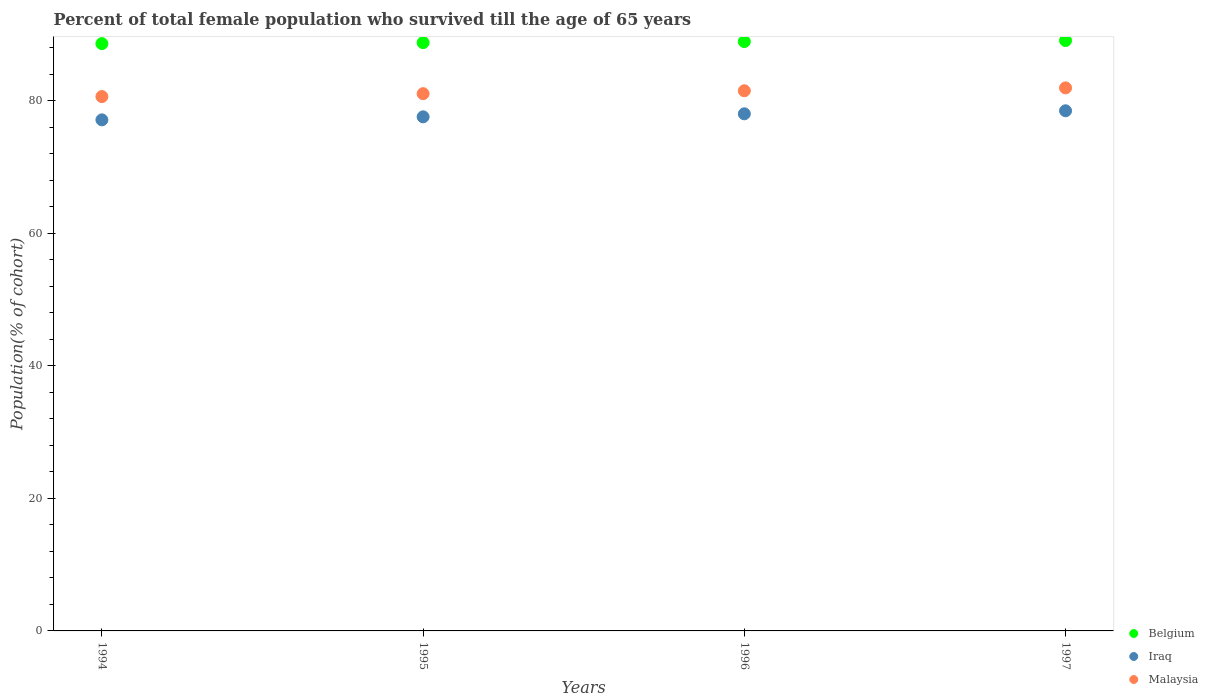How many different coloured dotlines are there?
Offer a very short reply. 3. What is the percentage of total female population who survived till the age of 65 years in Iraq in 1995?
Your answer should be very brief. 77.61. Across all years, what is the maximum percentage of total female population who survived till the age of 65 years in Belgium?
Offer a terse response. 89.12. Across all years, what is the minimum percentage of total female population who survived till the age of 65 years in Belgium?
Give a very brief answer. 88.66. What is the total percentage of total female population who survived till the age of 65 years in Malaysia in the graph?
Offer a very short reply. 325.29. What is the difference between the percentage of total female population who survived till the age of 65 years in Iraq in 1996 and that in 1997?
Make the answer very short. -0.46. What is the difference between the percentage of total female population who survived till the age of 65 years in Belgium in 1994 and the percentage of total female population who survived till the age of 65 years in Iraq in 1997?
Your answer should be very brief. 10.14. What is the average percentage of total female population who survived till the age of 65 years in Belgium per year?
Give a very brief answer. 88.89. In the year 1994, what is the difference between the percentage of total female population who survived till the age of 65 years in Belgium and percentage of total female population who survived till the age of 65 years in Malaysia?
Make the answer very short. 7.99. What is the ratio of the percentage of total female population who survived till the age of 65 years in Iraq in 1995 to that in 1997?
Your answer should be very brief. 0.99. Is the percentage of total female population who survived till the age of 65 years in Belgium in 1994 less than that in 1997?
Ensure brevity in your answer.  Yes. What is the difference between the highest and the second highest percentage of total female population who survived till the age of 65 years in Malaysia?
Provide a short and direct response. 0.44. What is the difference between the highest and the lowest percentage of total female population who survived till the age of 65 years in Iraq?
Your answer should be compact. 1.37. In how many years, is the percentage of total female population who survived till the age of 65 years in Iraq greater than the average percentage of total female population who survived till the age of 65 years in Iraq taken over all years?
Your response must be concise. 2. Is the sum of the percentage of total female population who survived till the age of 65 years in Belgium in 1994 and 1996 greater than the maximum percentage of total female population who survived till the age of 65 years in Iraq across all years?
Make the answer very short. Yes. Is it the case that in every year, the sum of the percentage of total female population who survived till the age of 65 years in Iraq and percentage of total female population who survived till the age of 65 years in Malaysia  is greater than the percentage of total female population who survived till the age of 65 years in Belgium?
Your answer should be compact. Yes. How many dotlines are there?
Your answer should be compact. 3. What is the difference between two consecutive major ticks on the Y-axis?
Offer a terse response. 20. Are the values on the major ticks of Y-axis written in scientific E-notation?
Make the answer very short. No. Does the graph contain grids?
Your response must be concise. No. Where does the legend appear in the graph?
Offer a very short reply. Bottom right. How many legend labels are there?
Ensure brevity in your answer.  3. What is the title of the graph?
Your answer should be compact. Percent of total female population who survived till the age of 65 years. Does "Puerto Rico" appear as one of the legend labels in the graph?
Keep it short and to the point. No. What is the label or title of the X-axis?
Your answer should be very brief. Years. What is the label or title of the Y-axis?
Give a very brief answer. Population(% of cohort). What is the Population(% of cohort) of Belgium in 1994?
Provide a succinct answer. 88.66. What is the Population(% of cohort) of Iraq in 1994?
Make the answer very short. 77.15. What is the Population(% of cohort) in Malaysia in 1994?
Offer a very short reply. 80.67. What is the Population(% of cohort) of Belgium in 1995?
Give a very brief answer. 88.81. What is the Population(% of cohort) in Iraq in 1995?
Your answer should be compact. 77.61. What is the Population(% of cohort) in Malaysia in 1995?
Your answer should be very brief. 81.1. What is the Population(% of cohort) of Belgium in 1996?
Keep it short and to the point. 88.97. What is the Population(% of cohort) of Iraq in 1996?
Your answer should be compact. 78.06. What is the Population(% of cohort) of Malaysia in 1996?
Your response must be concise. 81.54. What is the Population(% of cohort) of Belgium in 1997?
Your answer should be very brief. 89.12. What is the Population(% of cohort) of Iraq in 1997?
Keep it short and to the point. 78.52. What is the Population(% of cohort) of Malaysia in 1997?
Your answer should be very brief. 81.98. Across all years, what is the maximum Population(% of cohort) in Belgium?
Keep it short and to the point. 89.12. Across all years, what is the maximum Population(% of cohort) in Iraq?
Offer a terse response. 78.52. Across all years, what is the maximum Population(% of cohort) in Malaysia?
Ensure brevity in your answer.  81.98. Across all years, what is the minimum Population(% of cohort) of Belgium?
Offer a very short reply. 88.66. Across all years, what is the minimum Population(% of cohort) in Iraq?
Provide a short and direct response. 77.15. Across all years, what is the minimum Population(% of cohort) in Malaysia?
Offer a terse response. 80.67. What is the total Population(% of cohort) in Belgium in the graph?
Provide a succinct answer. 355.56. What is the total Population(% of cohort) of Iraq in the graph?
Provide a succinct answer. 311.34. What is the total Population(% of cohort) of Malaysia in the graph?
Provide a short and direct response. 325.29. What is the difference between the Population(% of cohort) in Belgium in 1994 and that in 1995?
Provide a short and direct response. -0.16. What is the difference between the Population(% of cohort) of Iraq in 1994 and that in 1995?
Offer a terse response. -0.46. What is the difference between the Population(% of cohort) of Malaysia in 1994 and that in 1995?
Keep it short and to the point. -0.44. What is the difference between the Population(% of cohort) in Belgium in 1994 and that in 1996?
Your answer should be very brief. -0.31. What is the difference between the Population(% of cohort) in Iraq in 1994 and that in 1996?
Your response must be concise. -0.91. What is the difference between the Population(% of cohort) of Malaysia in 1994 and that in 1996?
Keep it short and to the point. -0.87. What is the difference between the Population(% of cohort) of Belgium in 1994 and that in 1997?
Offer a very short reply. -0.47. What is the difference between the Population(% of cohort) of Iraq in 1994 and that in 1997?
Offer a very short reply. -1.37. What is the difference between the Population(% of cohort) in Malaysia in 1994 and that in 1997?
Ensure brevity in your answer.  -1.31. What is the difference between the Population(% of cohort) of Belgium in 1995 and that in 1996?
Your response must be concise. -0.16. What is the difference between the Population(% of cohort) in Iraq in 1995 and that in 1996?
Provide a succinct answer. -0.46. What is the difference between the Population(% of cohort) in Malaysia in 1995 and that in 1996?
Your answer should be compact. -0.44. What is the difference between the Population(% of cohort) in Belgium in 1995 and that in 1997?
Your answer should be very brief. -0.31. What is the difference between the Population(% of cohort) in Iraq in 1995 and that in 1997?
Offer a terse response. -0.91. What is the difference between the Population(% of cohort) in Malaysia in 1995 and that in 1997?
Offer a very short reply. -0.87. What is the difference between the Population(% of cohort) in Belgium in 1996 and that in 1997?
Your answer should be very brief. -0.16. What is the difference between the Population(% of cohort) in Iraq in 1996 and that in 1997?
Provide a succinct answer. -0.46. What is the difference between the Population(% of cohort) of Malaysia in 1996 and that in 1997?
Make the answer very short. -0.44. What is the difference between the Population(% of cohort) of Belgium in 1994 and the Population(% of cohort) of Iraq in 1995?
Offer a terse response. 11.05. What is the difference between the Population(% of cohort) of Belgium in 1994 and the Population(% of cohort) of Malaysia in 1995?
Your answer should be very brief. 7.55. What is the difference between the Population(% of cohort) in Iraq in 1994 and the Population(% of cohort) in Malaysia in 1995?
Your answer should be compact. -3.95. What is the difference between the Population(% of cohort) of Belgium in 1994 and the Population(% of cohort) of Iraq in 1996?
Your answer should be compact. 10.59. What is the difference between the Population(% of cohort) of Belgium in 1994 and the Population(% of cohort) of Malaysia in 1996?
Keep it short and to the point. 7.12. What is the difference between the Population(% of cohort) of Iraq in 1994 and the Population(% of cohort) of Malaysia in 1996?
Your response must be concise. -4.39. What is the difference between the Population(% of cohort) of Belgium in 1994 and the Population(% of cohort) of Iraq in 1997?
Ensure brevity in your answer.  10.14. What is the difference between the Population(% of cohort) in Belgium in 1994 and the Population(% of cohort) in Malaysia in 1997?
Offer a terse response. 6.68. What is the difference between the Population(% of cohort) of Iraq in 1994 and the Population(% of cohort) of Malaysia in 1997?
Your answer should be very brief. -4.83. What is the difference between the Population(% of cohort) in Belgium in 1995 and the Population(% of cohort) in Iraq in 1996?
Provide a succinct answer. 10.75. What is the difference between the Population(% of cohort) in Belgium in 1995 and the Population(% of cohort) in Malaysia in 1996?
Provide a succinct answer. 7.27. What is the difference between the Population(% of cohort) of Iraq in 1995 and the Population(% of cohort) of Malaysia in 1996?
Give a very brief answer. -3.93. What is the difference between the Population(% of cohort) in Belgium in 1995 and the Population(% of cohort) in Iraq in 1997?
Offer a terse response. 10.29. What is the difference between the Population(% of cohort) in Belgium in 1995 and the Population(% of cohort) in Malaysia in 1997?
Provide a succinct answer. 6.83. What is the difference between the Population(% of cohort) in Iraq in 1995 and the Population(% of cohort) in Malaysia in 1997?
Provide a succinct answer. -4.37. What is the difference between the Population(% of cohort) in Belgium in 1996 and the Population(% of cohort) in Iraq in 1997?
Provide a succinct answer. 10.45. What is the difference between the Population(% of cohort) in Belgium in 1996 and the Population(% of cohort) in Malaysia in 1997?
Give a very brief answer. 6.99. What is the difference between the Population(% of cohort) of Iraq in 1996 and the Population(% of cohort) of Malaysia in 1997?
Offer a very short reply. -3.91. What is the average Population(% of cohort) of Belgium per year?
Give a very brief answer. 88.89. What is the average Population(% of cohort) in Iraq per year?
Offer a very short reply. 77.83. What is the average Population(% of cohort) in Malaysia per year?
Your response must be concise. 81.32. In the year 1994, what is the difference between the Population(% of cohort) in Belgium and Population(% of cohort) in Iraq?
Give a very brief answer. 11.51. In the year 1994, what is the difference between the Population(% of cohort) of Belgium and Population(% of cohort) of Malaysia?
Your response must be concise. 7.99. In the year 1994, what is the difference between the Population(% of cohort) of Iraq and Population(% of cohort) of Malaysia?
Your answer should be compact. -3.52. In the year 1995, what is the difference between the Population(% of cohort) in Belgium and Population(% of cohort) in Iraq?
Your response must be concise. 11.21. In the year 1995, what is the difference between the Population(% of cohort) in Belgium and Population(% of cohort) in Malaysia?
Ensure brevity in your answer.  7.71. In the year 1995, what is the difference between the Population(% of cohort) of Iraq and Population(% of cohort) of Malaysia?
Your answer should be very brief. -3.5. In the year 1996, what is the difference between the Population(% of cohort) in Belgium and Population(% of cohort) in Iraq?
Offer a very short reply. 10.9. In the year 1996, what is the difference between the Population(% of cohort) of Belgium and Population(% of cohort) of Malaysia?
Make the answer very short. 7.43. In the year 1996, what is the difference between the Population(% of cohort) in Iraq and Population(% of cohort) in Malaysia?
Give a very brief answer. -3.48. In the year 1997, what is the difference between the Population(% of cohort) in Belgium and Population(% of cohort) in Iraq?
Make the answer very short. 10.6. In the year 1997, what is the difference between the Population(% of cohort) in Belgium and Population(% of cohort) in Malaysia?
Ensure brevity in your answer.  7.15. In the year 1997, what is the difference between the Population(% of cohort) of Iraq and Population(% of cohort) of Malaysia?
Keep it short and to the point. -3.46. What is the ratio of the Population(% of cohort) in Malaysia in 1994 to that in 1995?
Provide a succinct answer. 0.99. What is the ratio of the Population(% of cohort) of Belgium in 1994 to that in 1996?
Your answer should be compact. 1. What is the ratio of the Population(% of cohort) of Iraq in 1994 to that in 1996?
Provide a succinct answer. 0.99. What is the ratio of the Population(% of cohort) of Malaysia in 1994 to that in 1996?
Offer a very short reply. 0.99. What is the ratio of the Population(% of cohort) in Belgium in 1994 to that in 1997?
Provide a succinct answer. 0.99. What is the ratio of the Population(% of cohort) in Iraq in 1994 to that in 1997?
Keep it short and to the point. 0.98. What is the ratio of the Population(% of cohort) in Iraq in 1995 to that in 1996?
Your answer should be compact. 0.99. What is the ratio of the Population(% of cohort) of Malaysia in 1995 to that in 1996?
Your answer should be compact. 0.99. What is the ratio of the Population(% of cohort) of Iraq in 1995 to that in 1997?
Provide a succinct answer. 0.99. What is the ratio of the Population(% of cohort) of Malaysia in 1995 to that in 1997?
Ensure brevity in your answer.  0.99. What is the ratio of the Population(% of cohort) of Belgium in 1996 to that in 1997?
Give a very brief answer. 1. What is the ratio of the Population(% of cohort) of Malaysia in 1996 to that in 1997?
Ensure brevity in your answer.  0.99. What is the difference between the highest and the second highest Population(% of cohort) of Belgium?
Your response must be concise. 0.16. What is the difference between the highest and the second highest Population(% of cohort) in Iraq?
Provide a short and direct response. 0.46. What is the difference between the highest and the second highest Population(% of cohort) in Malaysia?
Ensure brevity in your answer.  0.44. What is the difference between the highest and the lowest Population(% of cohort) in Belgium?
Your answer should be compact. 0.47. What is the difference between the highest and the lowest Population(% of cohort) of Iraq?
Your answer should be very brief. 1.37. What is the difference between the highest and the lowest Population(% of cohort) in Malaysia?
Offer a terse response. 1.31. 